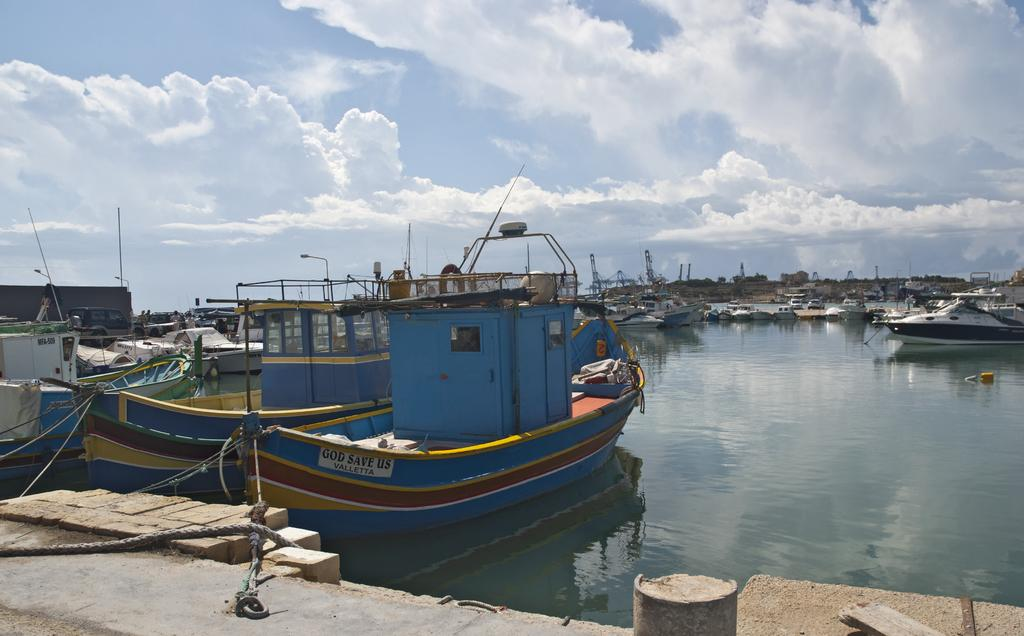What type of body of water is present in the image? There is a sea in the image. What can be seen floating on the sea? There are boats in the sea. What is visible in the background of the image? The sky is visible in the background of the image. How would you describe the weather based on the appearance of the sky? The sky appears to be cloudy, which might suggest overcast or potentially rainy weather. How many spoons are floating on the waves in the image? There are no spoons present in the image, and the image does not depict waves. 